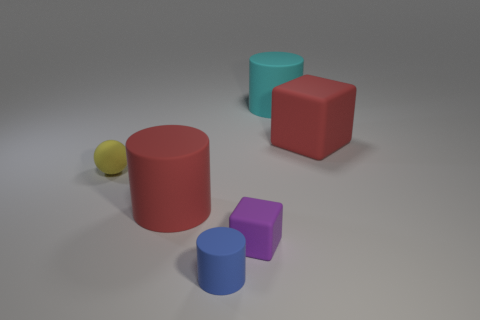Is the color of the tiny matte cylinder the same as the large cylinder that is to the left of the small matte cylinder?
Offer a terse response. No. What is the cylinder that is behind the blue cylinder and in front of the cyan cylinder made of?
Keep it short and to the point. Rubber. What is the size of the thing that is the same color as the large block?
Make the answer very short. Large. There is a red thing that is on the right side of the red matte cylinder; does it have the same shape as the big red object that is on the left side of the red cube?
Your response must be concise. No. Are there any tiny blue metallic things?
Offer a very short reply. No. The other tiny thing that is the same shape as the cyan matte thing is what color?
Make the answer very short. Blue. What is the color of the ball that is the same size as the blue object?
Your answer should be very brief. Yellow. Is the material of the red cylinder the same as the cyan thing?
Make the answer very short. Yes. What number of matte spheres are the same color as the tiny cylinder?
Your answer should be compact. 0. Do the ball and the large matte block have the same color?
Ensure brevity in your answer.  No. 